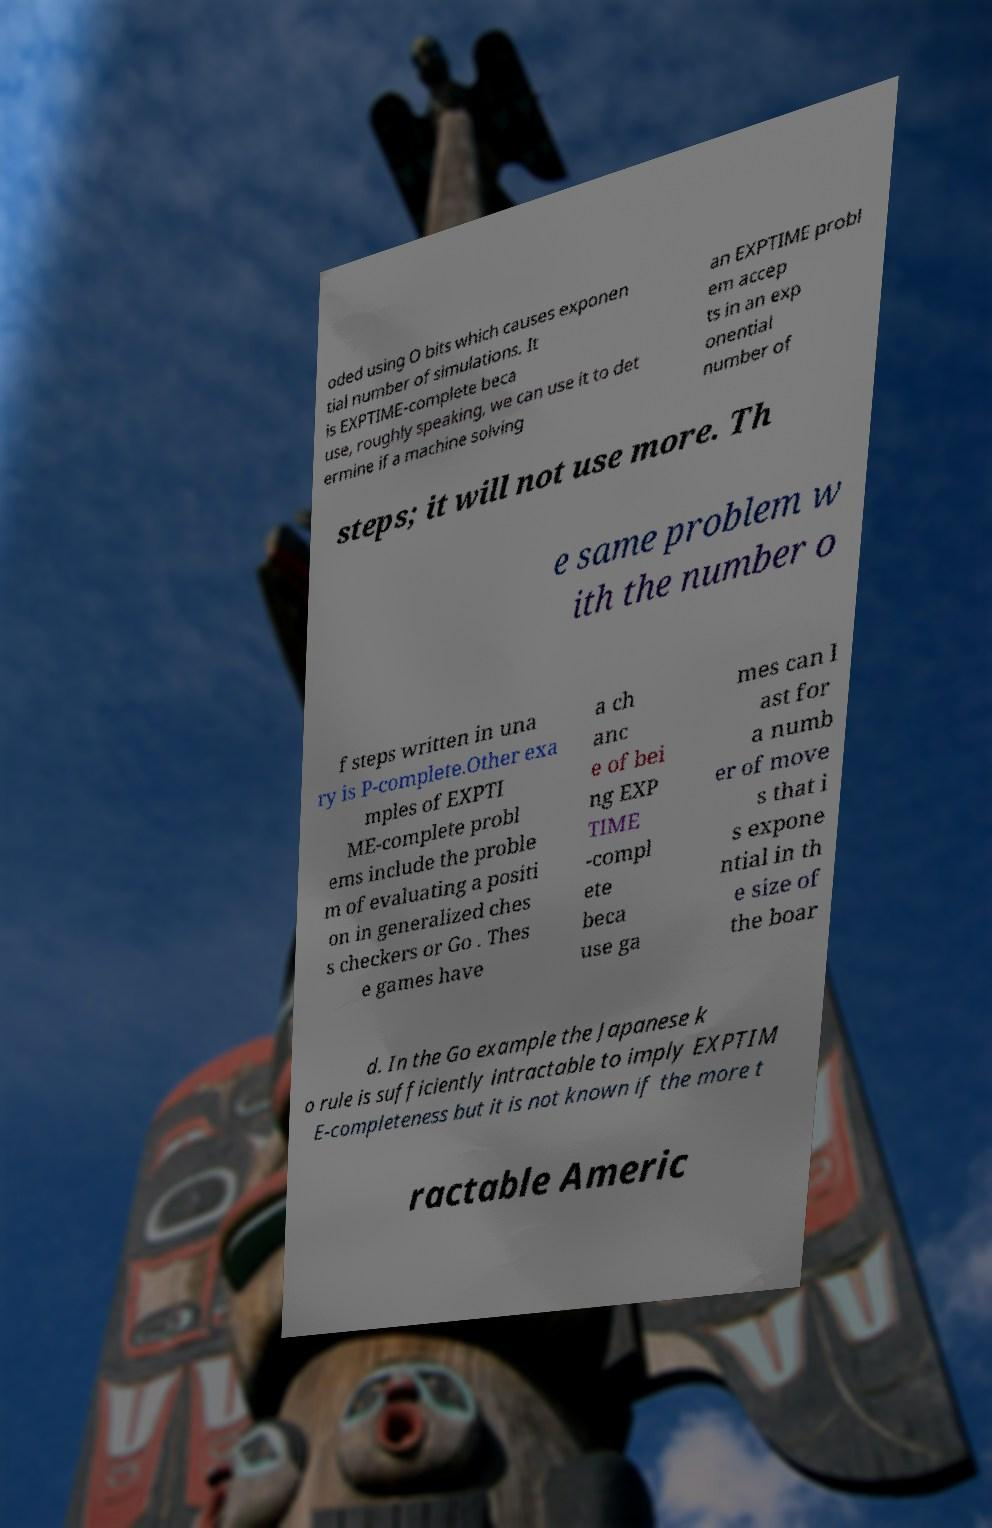There's text embedded in this image that I need extracted. Can you transcribe it verbatim? oded using O bits which causes exponen tial number of simulations. It is EXPTIME-complete beca use, roughly speaking, we can use it to det ermine if a machine solving an EXPTIME probl em accep ts in an exp onential number of steps; it will not use more. Th e same problem w ith the number o f steps written in una ry is P-complete.Other exa mples of EXPTI ME-complete probl ems include the proble m of evaluating a positi on in generalized ches s checkers or Go . Thes e games have a ch anc e of bei ng EXP TIME -compl ete beca use ga mes can l ast for a numb er of move s that i s expone ntial in th e size of the boar d. In the Go example the Japanese k o rule is sufficiently intractable to imply EXPTIM E-completeness but it is not known if the more t ractable Americ 